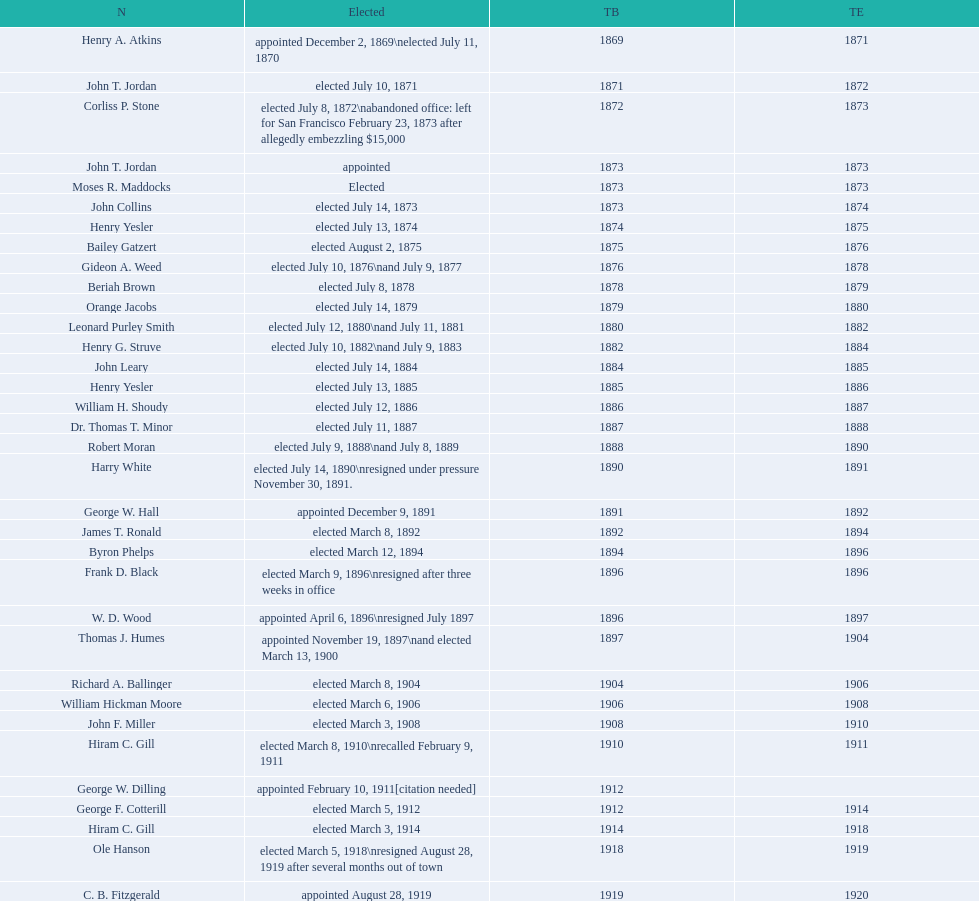Who was the sole individual chosen in 1871? John T. Jordan. 